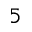Convert formula to latex. <formula><loc_0><loc_0><loc_500><loc_500>5</formula> 